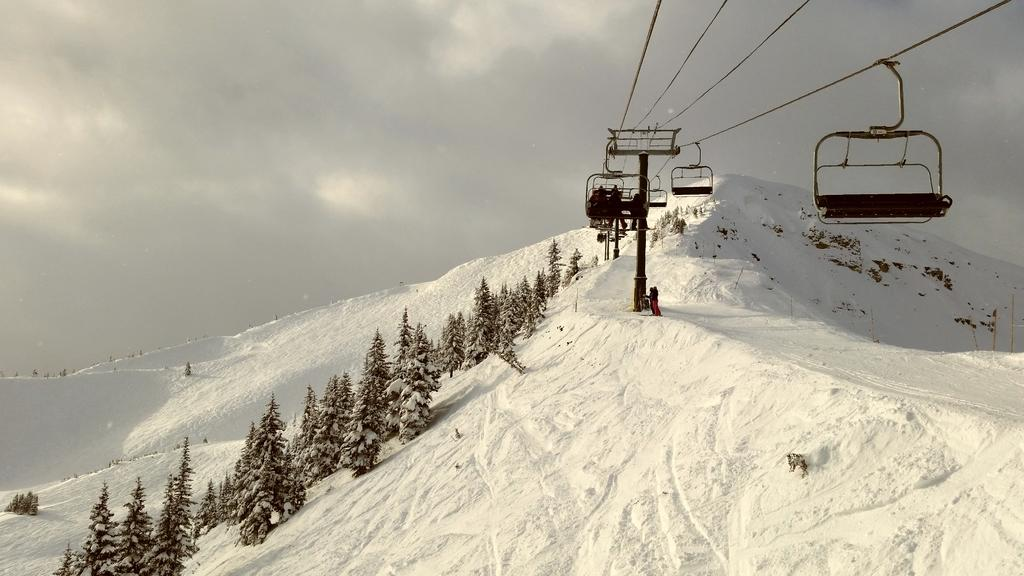What type of vegetation can be seen in the image? There are trees in the image. What mode of transportation is present in the image? There are cable cars in the image. Are there any people visible in the image? Yes, there are people in the image. What is the weather like in the image? There is snow visible in the image, indicating a cold or snowy environment. What is visible at the top of the image? The sky is visible at the top of the image. Can you hear the people in the image crying? There is no indication of sound or emotion in the image, so it is not possible to determine if the people are crying. What type of ticket is required to ride the slope in the image? There is no slope present in the image, and therefore no ticket is required for it. 